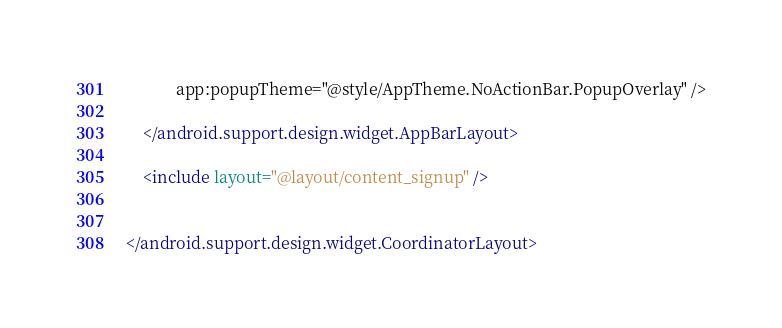Convert code to text. <code><loc_0><loc_0><loc_500><loc_500><_XML_>            app:popupTheme="@style/AppTheme.NoActionBar.PopupOverlay" />

    </android.support.design.widget.AppBarLayout>

    <include layout="@layout/content_signup" />


</android.support.design.widget.CoordinatorLayout>
</code> 